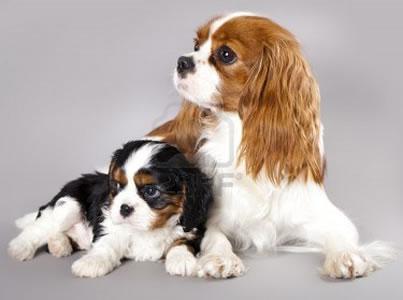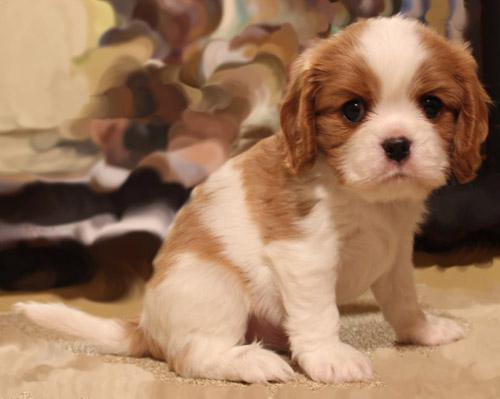The first image is the image on the left, the second image is the image on the right. Analyze the images presented: Is the assertion "Ine one of the images only the dog's head is visible" valid? Answer yes or no. No. 